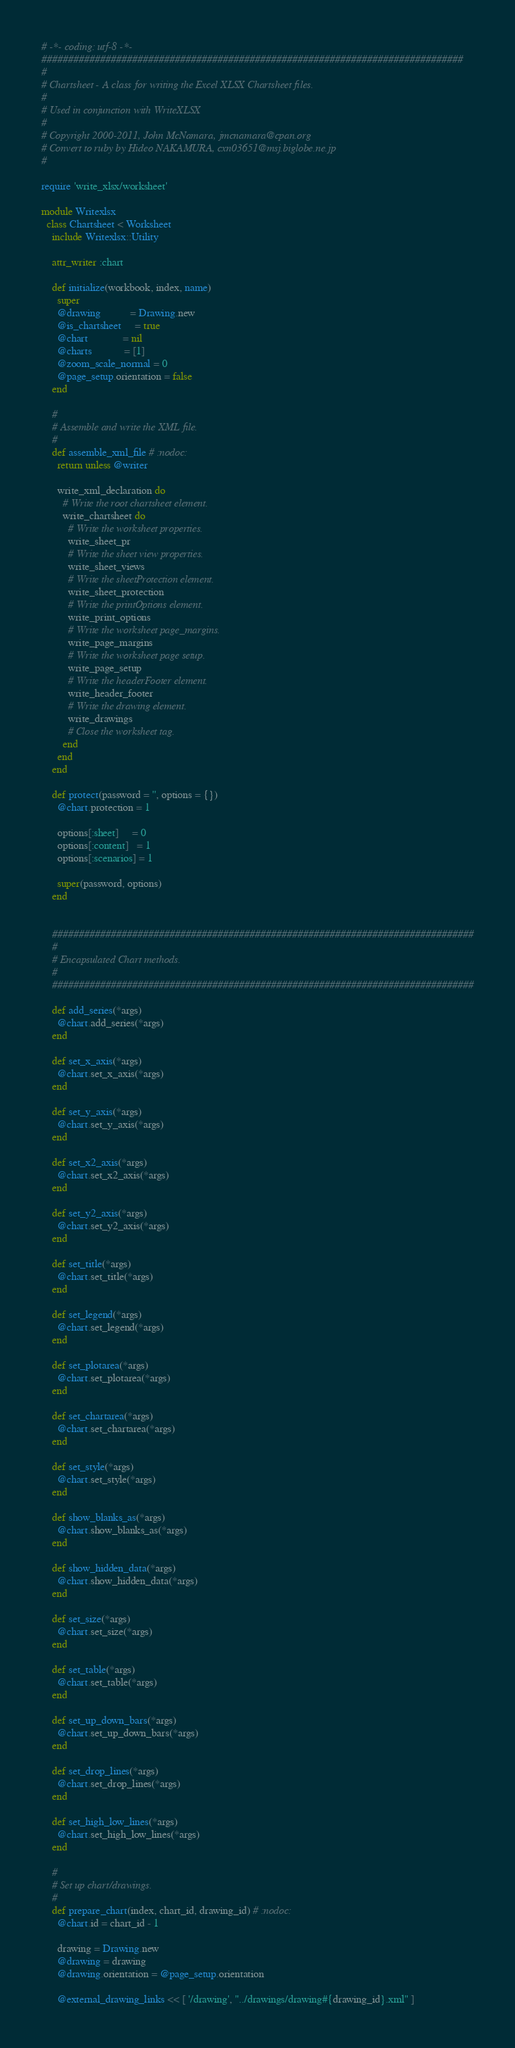Convert code to text. <code><loc_0><loc_0><loc_500><loc_500><_Ruby_># -*- coding: utf-8 -*-
###############################################################################
#
# Chartsheet - A class for writing the Excel XLSX Chartsheet files.
#
# Used in conjunction with WriteXLSX
#
# Copyright 2000-2011, John McNamara, jmcnamara@cpan.org
# Convert to ruby by Hideo NAKAMURA, cxn03651@msj.biglobe.ne.jp
#

require 'write_xlsx/worksheet'

module Writexlsx
  class Chartsheet < Worksheet
    include Writexlsx::Utility

    attr_writer :chart

    def initialize(workbook, index, name)
      super
      @drawing           = Drawing.new
      @is_chartsheet     = true
      @chart             = nil
      @charts            = [1]
      @zoom_scale_normal = 0
      @page_setup.orientation = false
    end

    #
    # Assemble and write the XML file.
    #
    def assemble_xml_file # :nodoc:
      return unless @writer

      write_xml_declaration do
        # Write the root chartsheet element.
        write_chartsheet do
          # Write the worksheet properties.
          write_sheet_pr
          # Write the sheet view properties.
          write_sheet_views
          # Write the sheetProtection element.
          write_sheet_protection
          # Write the printOptions element.
          write_print_options
          # Write the worksheet page_margins.
          write_page_margins
          # Write the worksheet page setup.
          write_page_setup
          # Write the headerFooter element.
          write_header_footer
          # Write the drawing element.
          write_drawings
          # Close the worksheet tag.
        end
      end
    end

    def protect(password = '', options = {})
      @chart.protection = 1

      options[:sheet]     = 0
      options[:content]   = 1
      options[:scenarios] = 1

      super(password, options)
    end


    ###############################################################################
    #
    # Encapsulated Chart methods.
    #
    ###############################################################################

    def add_series(*args)
      @chart.add_series(*args)
    end

    def set_x_axis(*args)
      @chart.set_x_axis(*args)
    end

    def set_y_axis(*args)
      @chart.set_y_axis(*args)
    end

    def set_x2_axis(*args)
      @chart.set_x2_axis(*args)
    end

    def set_y2_axis(*args)
      @chart.set_y2_axis(*args)
    end

    def set_title(*args)
      @chart.set_title(*args)
    end

    def set_legend(*args)
      @chart.set_legend(*args)
    end

    def set_plotarea(*args)
      @chart.set_plotarea(*args)
    end

    def set_chartarea(*args)
      @chart.set_chartarea(*args)
    end

    def set_style(*args)
      @chart.set_style(*args)
    end

    def show_blanks_as(*args)
      @chart.show_blanks_as(*args)
    end

    def show_hidden_data(*args)
      @chart.show_hidden_data(*args)
    end

    def set_size(*args)
      @chart.set_size(*args)
    end

    def set_table(*args)
      @chart.set_table(*args)
    end

    def set_up_down_bars(*args)
      @chart.set_up_down_bars(*args)
    end

    def set_drop_lines(*args)
      @chart.set_drop_lines(*args)
    end

    def set_high_low_lines(*args)
      @chart.set_high_low_lines(*args)
    end

    #
    # Set up chart/drawings.
    #
    def prepare_chart(index, chart_id, drawing_id) # :nodoc:
      @chart.id = chart_id - 1

      drawing = Drawing.new
      @drawing = drawing
      @drawing.orientation = @page_setup.orientation

      @external_drawing_links << [ '/drawing', "../drawings/drawing#{drawing_id}.xml" ]
</code> 